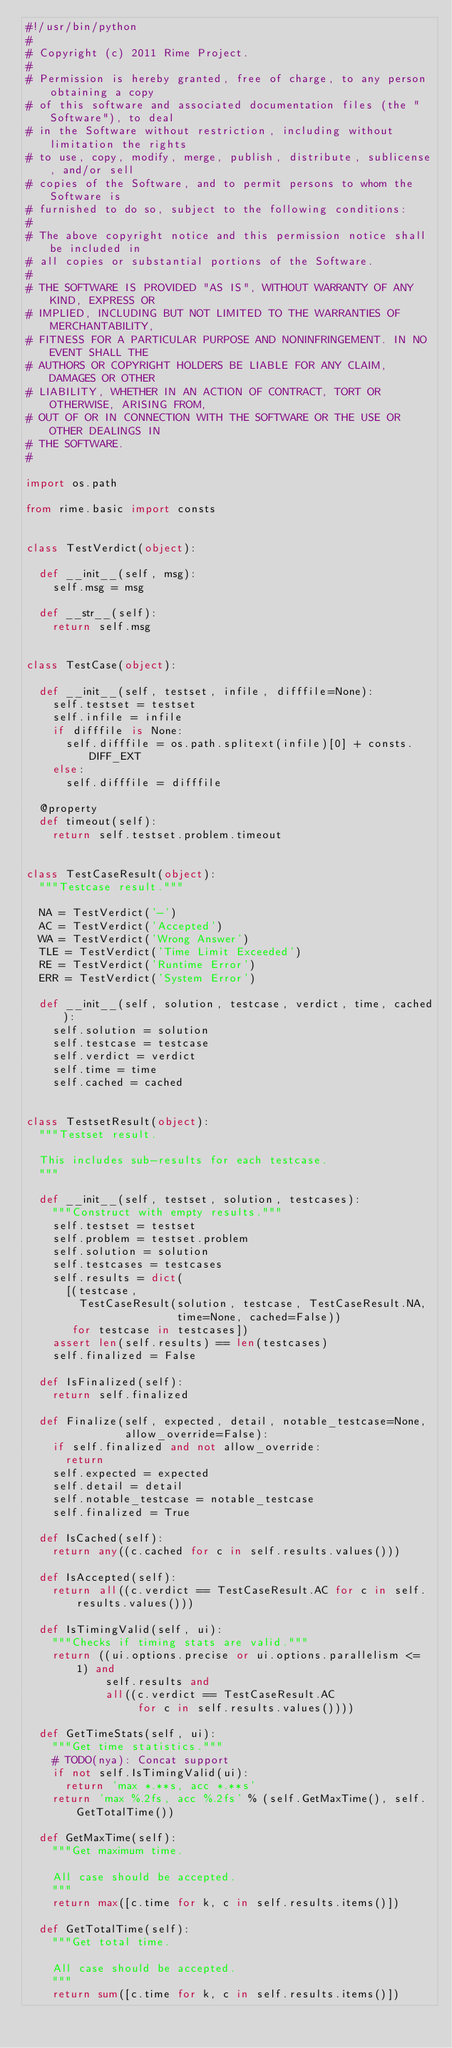Convert code to text. <code><loc_0><loc_0><loc_500><loc_500><_Python_>#!/usr/bin/python
#
# Copyright (c) 2011 Rime Project.
#
# Permission is hereby granted, free of charge, to any person obtaining a copy
# of this software and associated documentation files (the "Software"), to deal
# in the Software without restriction, including without limitation the rights
# to use, copy, modify, merge, publish, distribute, sublicense, and/or sell
# copies of the Software, and to permit persons to whom the Software is
# furnished to do so, subject to the following conditions:
#
# The above copyright notice and this permission notice shall be included in
# all copies or substantial portions of the Software.
#
# THE SOFTWARE IS PROVIDED "AS IS", WITHOUT WARRANTY OF ANY KIND, EXPRESS OR
# IMPLIED, INCLUDING BUT NOT LIMITED TO THE WARRANTIES OF MERCHANTABILITY,
# FITNESS FOR A PARTICULAR PURPOSE AND NONINFRINGEMENT. IN NO EVENT SHALL THE
# AUTHORS OR COPYRIGHT HOLDERS BE LIABLE FOR ANY CLAIM, DAMAGES OR OTHER
# LIABILITY, WHETHER IN AN ACTION OF CONTRACT, TORT OR OTHERWISE, ARISING FROM,
# OUT OF OR IN CONNECTION WITH THE SOFTWARE OR THE USE OR OTHER DEALINGS IN
# THE SOFTWARE.
#

import os.path

from rime.basic import consts


class TestVerdict(object):

  def __init__(self, msg):
    self.msg = msg

  def __str__(self):
    return self.msg


class TestCase(object):

  def __init__(self, testset, infile, difffile=None):
    self.testset = testset
    self.infile = infile
    if difffile is None:
      self.difffile = os.path.splitext(infile)[0] + consts.DIFF_EXT
    else:
      self.difffile = difffile

  @property
  def timeout(self):
    return self.testset.problem.timeout


class TestCaseResult(object):
  """Testcase result."""

  NA = TestVerdict('-')
  AC = TestVerdict('Accepted')
  WA = TestVerdict('Wrong Answer')
  TLE = TestVerdict('Time Limit Exceeded')
  RE = TestVerdict('Runtime Error')
  ERR = TestVerdict('System Error')

  def __init__(self, solution, testcase, verdict, time, cached):
    self.solution = solution
    self.testcase = testcase
    self.verdict = verdict
    self.time = time
    self.cached = cached


class TestsetResult(object):
  """Testset result.

  This includes sub-results for each testcase.
  """

  def __init__(self, testset, solution, testcases):
    """Construct with empty results."""
    self.testset = testset
    self.problem = testset.problem
    self.solution = solution
    self.testcases = testcases
    self.results = dict(
      [(testcase,
        TestCaseResult(solution, testcase, TestCaseResult.NA,
                       time=None, cached=False))
       for testcase in testcases])
    assert len(self.results) == len(testcases)
    self.finalized = False

  def IsFinalized(self):
    return self.finalized

  def Finalize(self, expected, detail, notable_testcase=None,
               allow_override=False):
    if self.finalized and not allow_override:
      return
    self.expected = expected
    self.detail = detail
    self.notable_testcase = notable_testcase
    self.finalized = True

  def IsCached(self):
    return any((c.cached for c in self.results.values()))

  def IsAccepted(self):
    return all((c.verdict == TestCaseResult.AC for c in self.results.values()))

  def IsTimingValid(self, ui):
    """Checks if timing stats are valid."""
    return ((ui.options.precise or ui.options.parallelism <= 1) and
            self.results and
            all((c.verdict == TestCaseResult.AC
                 for c in self.results.values())))

  def GetTimeStats(self, ui):
    """Get time statistics."""
    # TODO(nya): Concat support
    if not self.IsTimingValid(ui):
      return 'max *.**s, acc *.**s'
    return 'max %.2fs, acc %.2fs' % (self.GetMaxTime(), self.GetTotalTime())

  def GetMaxTime(self):
    """Get maximum time.

    All case should be accepted.
    """
    return max([c.time for k, c in self.results.items()])

  def GetTotalTime(self):
    """Get total time.

    All case should be accepted.
    """
    return sum([c.time for k, c in self.results.items()])
</code> 